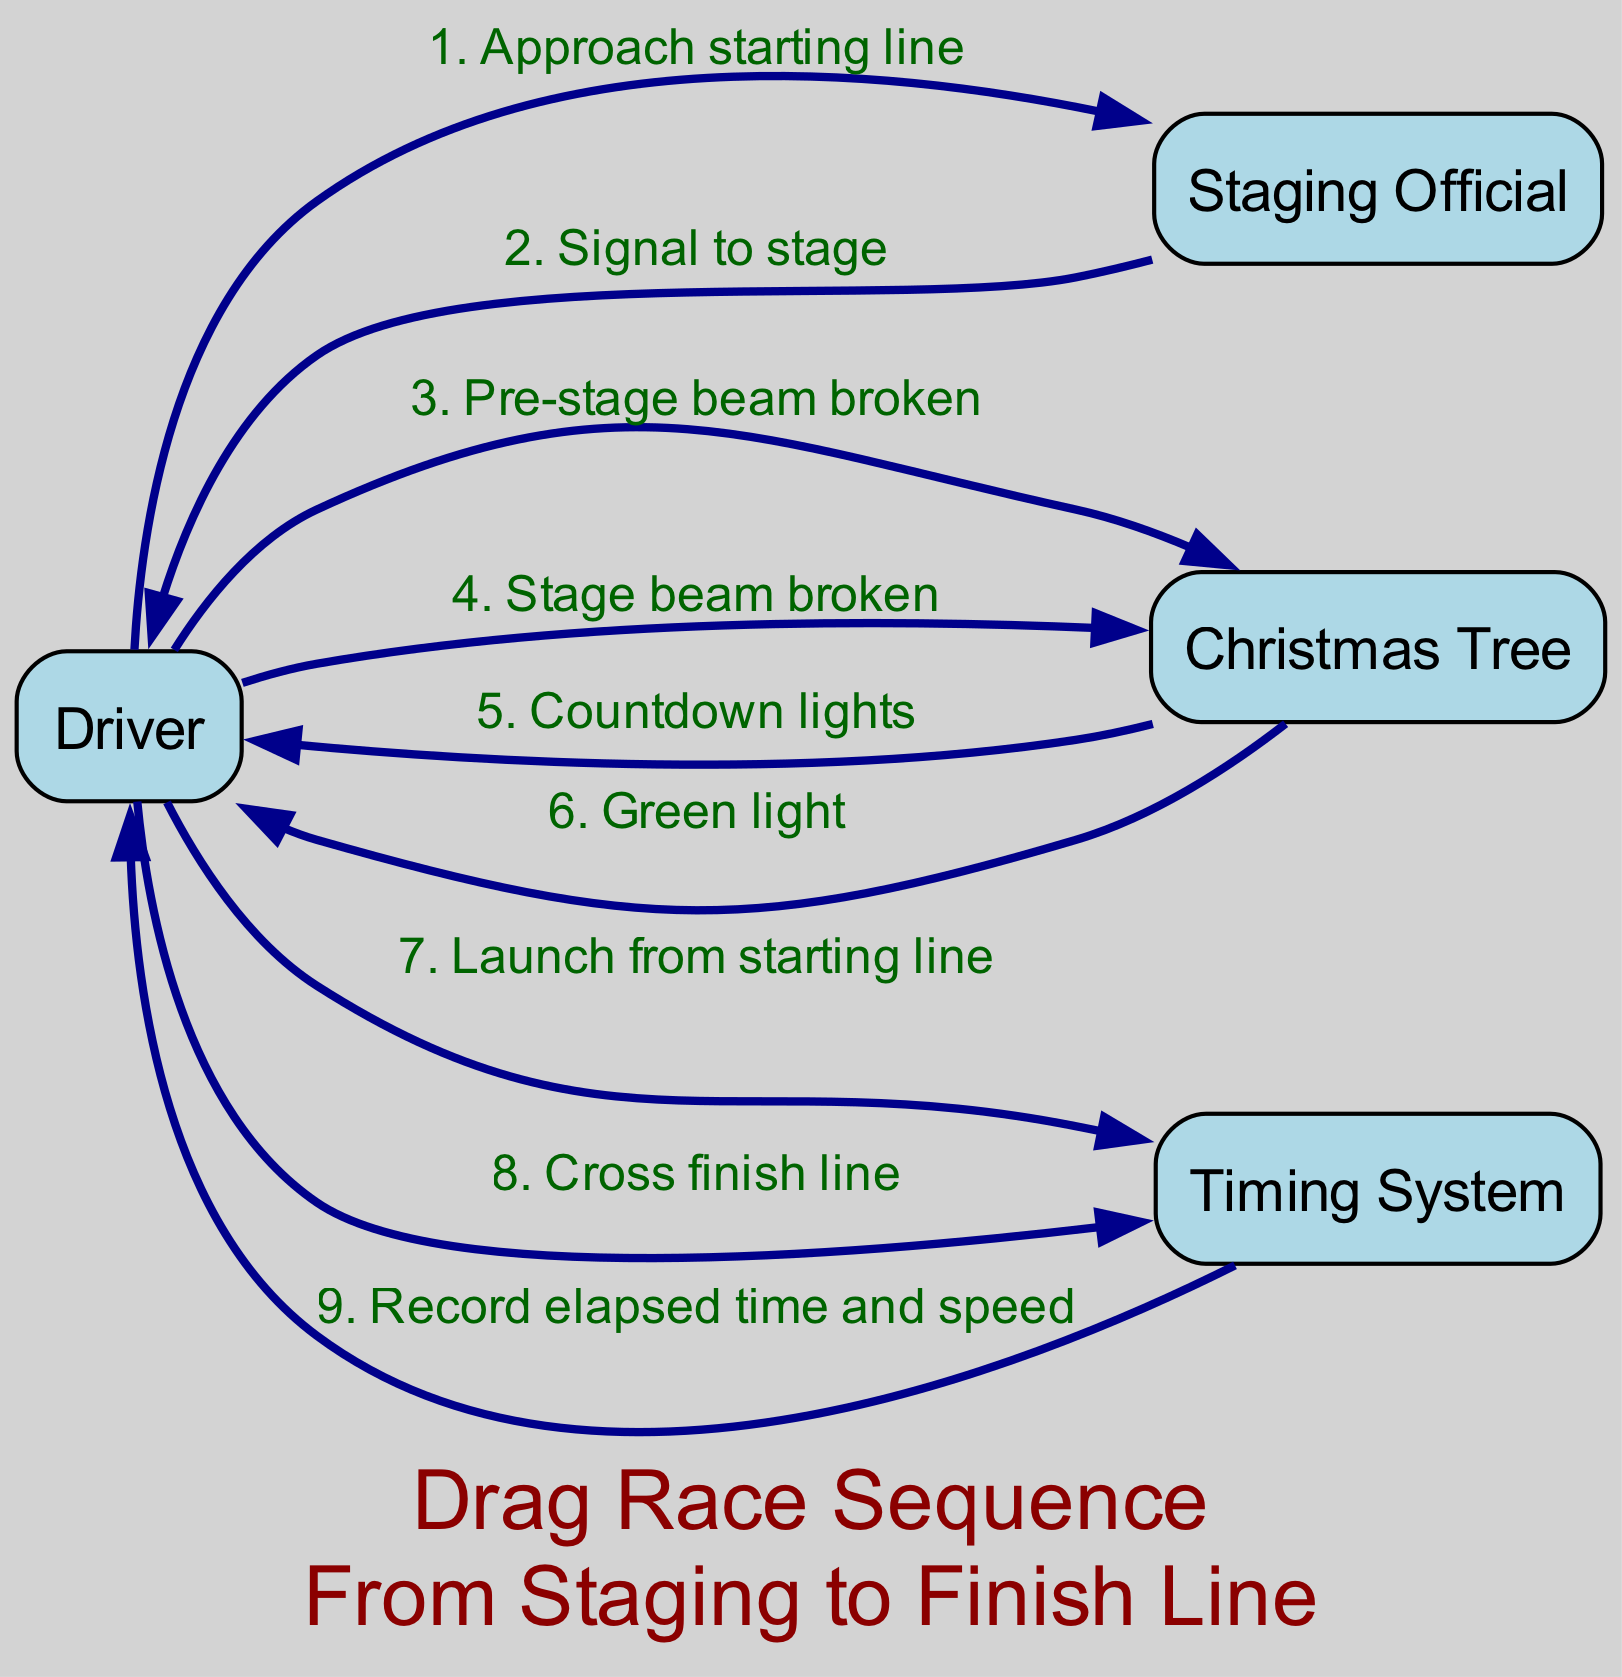What is the first action the Driver takes in the race? The sequence shows that the first action is for the Driver to "Approach starting line" as indicated in the first step from Driver to Staging Official.
Answer: Approach starting line How many participants are involved in the drag race? The diagram lists four participants: Driver, Staging Official, Christmas Tree, and Timing System, which can be counted directly from the participants' list.
Answer: 4 What signal does the Staging Official give to the Driver? According to the second step of the sequence, the Staging Official sends the message "Signal to stage" to the Driver.
Answer: Signal to stage What action does the Driver perform after breaking the stage beam? After breaking the stage beam, the Driver is shown as entering into the countdown phase with the Christmas Tree, which is represented by the next step "Countdown lights".
Answer: Countdown lights What happens after the Green light is shown? Following the Green light, the next action is the Driver launching from the starting line, which is seen in the step from Driver to Timing System.
Answer: Launch from starting line How many messages are recorded by the Timing System? The Timing System records two messages: "Launch from starting line" and "Cross finish line". Counting these shows there are two interactions.
Answer: 2 What is the last action in the sequence diagram? The final action in the sequence is the Timing System recording the "elapsed time and speed" after the Driver crosses the finish line.
Answer: Record elapsed time and speed What event does the Driver initiate to begin the drag race? The Driver initiates the event of launching from the starting line after the green light, which is clearly defined as a direct action in the sequence.
Answer: Launch from starting line Which participant signals the Driver to stage? The Staging Official is responsible for signaling the Driver to stage, verified by the directed message in the sequence.
Answer: Staging Official 